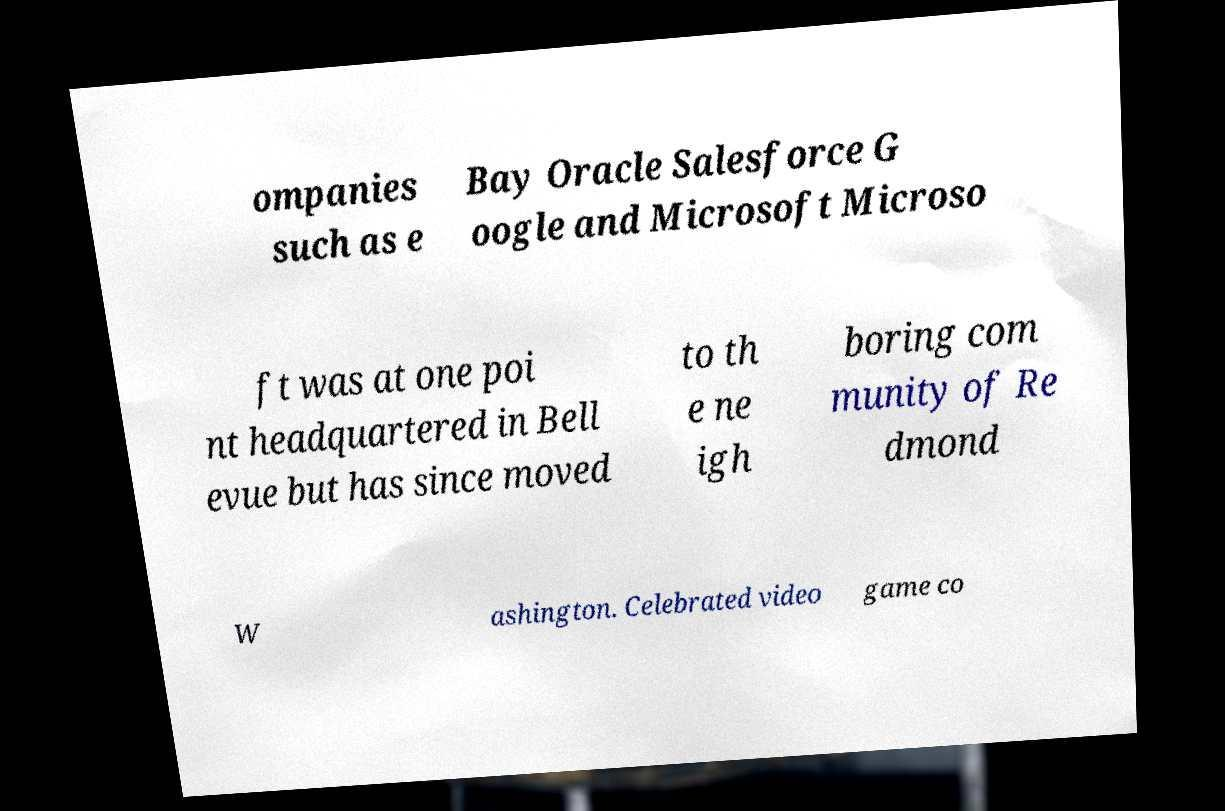Can you accurately transcribe the text from the provided image for me? ompanies such as e Bay Oracle Salesforce G oogle and Microsoft Microso ft was at one poi nt headquartered in Bell evue but has since moved to th e ne igh boring com munity of Re dmond W ashington. Celebrated video game co 